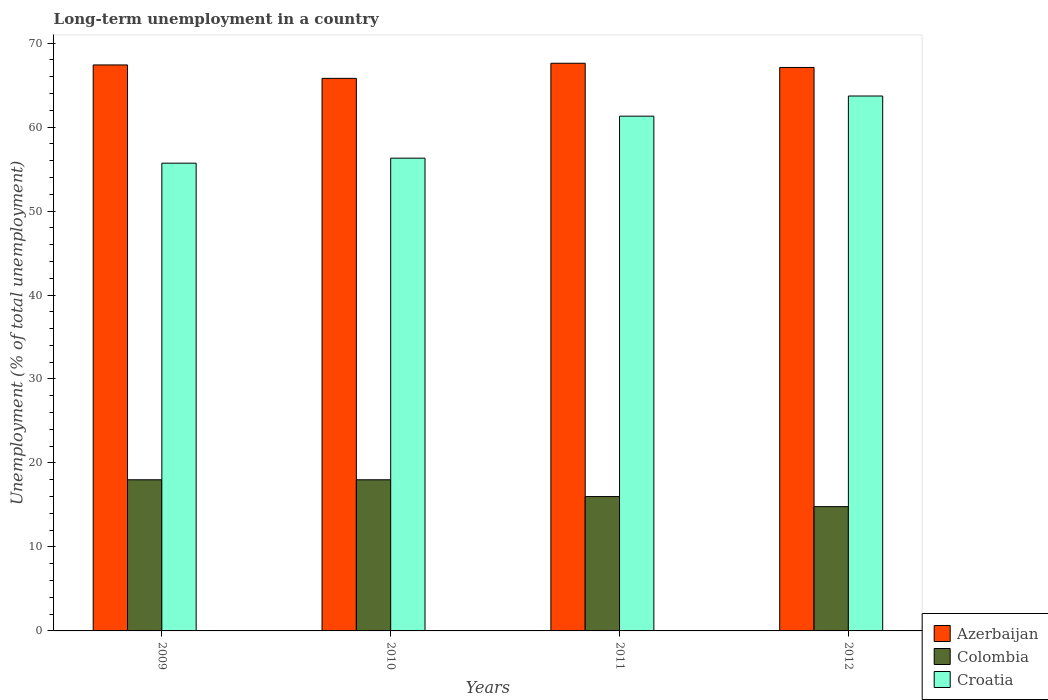Are the number of bars on each tick of the X-axis equal?
Offer a very short reply. Yes. How many bars are there on the 1st tick from the left?
Give a very brief answer. 3. What is the percentage of long-term unemployed population in Azerbaijan in 2009?
Keep it short and to the point. 67.4. Across all years, what is the maximum percentage of long-term unemployed population in Croatia?
Offer a very short reply. 63.7. Across all years, what is the minimum percentage of long-term unemployed population in Croatia?
Offer a very short reply. 55.7. In which year was the percentage of long-term unemployed population in Croatia maximum?
Provide a succinct answer. 2012. In which year was the percentage of long-term unemployed population in Colombia minimum?
Give a very brief answer. 2012. What is the total percentage of long-term unemployed population in Croatia in the graph?
Ensure brevity in your answer.  237. What is the difference between the percentage of long-term unemployed population in Croatia in 2010 and that in 2012?
Make the answer very short. -7.4. What is the difference between the percentage of long-term unemployed population in Colombia in 2010 and the percentage of long-term unemployed population in Azerbaijan in 2009?
Provide a short and direct response. -49.4. What is the average percentage of long-term unemployed population in Azerbaijan per year?
Make the answer very short. 66.98. In the year 2011, what is the difference between the percentage of long-term unemployed population in Colombia and percentage of long-term unemployed population in Azerbaijan?
Provide a succinct answer. -51.6. In how many years, is the percentage of long-term unemployed population in Croatia greater than 68 %?
Ensure brevity in your answer.  0. What is the ratio of the percentage of long-term unemployed population in Colombia in 2010 to that in 2011?
Provide a short and direct response. 1.12. Is the percentage of long-term unemployed population in Azerbaijan in 2010 less than that in 2012?
Offer a very short reply. Yes. What is the difference between the highest and the second highest percentage of long-term unemployed population in Croatia?
Give a very brief answer. 2.4. What is the difference between the highest and the lowest percentage of long-term unemployed population in Colombia?
Provide a short and direct response. 3.2. What does the 3rd bar from the left in 2009 represents?
Ensure brevity in your answer.  Croatia. What does the 2nd bar from the right in 2010 represents?
Your answer should be compact. Colombia. How many years are there in the graph?
Offer a terse response. 4. Does the graph contain any zero values?
Give a very brief answer. No. What is the title of the graph?
Make the answer very short. Long-term unemployment in a country. Does "Namibia" appear as one of the legend labels in the graph?
Provide a succinct answer. No. What is the label or title of the X-axis?
Provide a short and direct response. Years. What is the label or title of the Y-axis?
Offer a very short reply. Unemployment (% of total unemployment). What is the Unemployment (% of total unemployment) in Azerbaijan in 2009?
Offer a very short reply. 67.4. What is the Unemployment (% of total unemployment) of Colombia in 2009?
Keep it short and to the point. 18. What is the Unemployment (% of total unemployment) of Croatia in 2009?
Offer a terse response. 55.7. What is the Unemployment (% of total unemployment) of Azerbaijan in 2010?
Keep it short and to the point. 65.8. What is the Unemployment (% of total unemployment) in Colombia in 2010?
Give a very brief answer. 18. What is the Unemployment (% of total unemployment) in Croatia in 2010?
Give a very brief answer. 56.3. What is the Unemployment (% of total unemployment) in Azerbaijan in 2011?
Ensure brevity in your answer.  67.6. What is the Unemployment (% of total unemployment) in Colombia in 2011?
Your answer should be compact. 16. What is the Unemployment (% of total unemployment) in Croatia in 2011?
Make the answer very short. 61.3. What is the Unemployment (% of total unemployment) of Azerbaijan in 2012?
Your answer should be compact. 67.1. What is the Unemployment (% of total unemployment) of Colombia in 2012?
Give a very brief answer. 14.8. What is the Unemployment (% of total unemployment) of Croatia in 2012?
Your answer should be very brief. 63.7. Across all years, what is the maximum Unemployment (% of total unemployment) of Azerbaijan?
Your response must be concise. 67.6. Across all years, what is the maximum Unemployment (% of total unemployment) in Colombia?
Your answer should be very brief. 18. Across all years, what is the maximum Unemployment (% of total unemployment) in Croatia?
Your response must be concise. 63.7. Across all years, what is the minimum Unemployment (% of total unemployment) of Azerbaijan?
Offer a terse response. 65.8. Across all years, what is the minimum Unemployment (% of total unemployment) in Colombia?
Offer a very short reply. 14.8. Across all years, what is the minimum Unemployment (% of total unemployment) in Croatia?
Provide a short and direct response. 55.7. What is the total Unemployment (% of total unemployment) in Azerbaijan in the graph?
Make the answer very short. 267.9. What is the total Unemployment (% of total unemployment) in Colombia in the graph?
Make the answer very short. 66.8. What is the total Unemployment (% of total unemployment) in Croatia in the graph?
Ensure brevity in your answer.  237. What is the difference between the Unemployment (% of total unemployment) of Croatia in 2009 and that in 2011?
Make the answer very short. -5.6. What is the difference between the Unemployment (% of total unemployment) of Azerbaijan in 2010 and that in 2011?
Offer a very short reply. -1.8. What is the difference between the Unemployment (% of total unemployment) of Colombia in 2010 and that in 2011?
Give a very brief answer. 2. What is the difference between the Unemployment (% of total unemployment) in Azerbaijan in 2010 and that in 2012?
Offer a very short reply. -1.3. What is the difference between the Unemployment (% of total unemployment) in Colombia in 2010 and that in 2012?
Provide a short and direct response. 3.2. What is the difference between the Unemployment (% of total unemployment) of Croatia in 2010 and that in 2012?
Offer a very short reply. -7.4. What is the difference between the Unemployment (% of total unemployment) of Azerbaijan in 2009 and the Unemployment (% of total unemployment) of Colombia in 2010?
Your answer should be compact. 49.4. What is the difference between the Unemployment (% of total unemployment) of Colombia in 2009 and the Unemployment (% of total unemployment) of Croatia in 2010?
Provide a short and direct response. -38.3. What is the difference between the Unemployment (% of total unemployment) of Azerbaijan in 2009 and the Unemployment (% of total unemployment) of Colombia in 2011?
Keep it short and to the point. 51.4. What is the difference between the Unemployment (% of total unemployment) in Azerbaijan in 2009 and the Unemployment (% of total unemployment) in Croatia in 2011?
Give a very brief answer. 6.1. What is the difference between the Unemployment (% of total unemployment) in Colombia in 2009 and the Unemployment (% of total unemployment) in Croatia in 2011?
Provide a succinct answer. -43.3. What is the difference between the Unemployment (% of total unemployment) of Azerbaijan in 2009 and the Unemployment (% of total unemployment) of Colombia in 2012?
Your answer should be compact. 52.6. What is the difference between the Unemployment (% of total unemployment) in Azerbaijan in 2009 and the Unemployment (% of total unemployment) in Croatia in 2012?
Offer a very short reply. 3.7. What is the difference between the Unemployment (% of total unemployment) in Colombia in 2009 and the Unemployment (% of total unemployment) in Croatia in 2012?
Keep it short and to the point. -45.7. What is the difference between the Unemployment (% of total unemployment) of Azerbaijan in 2010 and the Unemployment (% of total unemployment) of Colombia in 2011?
Ensure brevity in your answer.  49.8. What is the difference between the Unemployment (% of total unemployment) in Azerbaijan in 2010 and the Unemployment (% of total unemployment) in Croatia in 2011?
Make the answer very short. 4.5. What is the difference between the Unemployment (% of total unemployment) of Colombia in 2010 and the Unemployment (% of total unemployment) of Croatia in 2011?
Your answer should be very brief. -43.3. What is the difference between the Unemployment (% of total unemployment) in Azerbaijan in 2010 and the Unemployment (% of total unemployment) in Colombia in 2012?
Give a very brief answer. 51. What is the difference between the Unemployment (% of total unemployment) of Azerbaijan in 2010 and the Unemployment (% of total unemployment) of Croatia in 2012?
Your answer should be compact. 2.1. What is the difference between the Unemployment (% of total unemployment) in Colombia in 2010 and the Unemployment (% of total unemployment) in Croatia in 2012?
Provide a succinct answer. -45.7. What is the difference between the Unemployment (% of total unemployment) in Azerbaijan in 2011 and the Unemployment (% of total unemployment) in Colombia in 2012?
Your answer should be very brief. 52.8. What is the difference between the Unemployment (% of total unemployment) of Azerbaijan in 2011 and the Unemployment (% of total unemployment) of Croatia in 2012?
Your answer should be very brief. 3.9. What is the difference between the Unemployment (% of total unemployment) in Colombia in 2011 and the Unemployment (% of total unemployment) in Croatia in 2012?
Your answer should be very brief. -47.7. What is the average Unemployment (% of total unemployment) in Azerbaijan per year?
Make the answer very short. 66.97. What is the average Unemployment (% of total unemployment) in Croatia per year?
Provide a succinct answer. 59.25. In the year 2009, what is the difference between the Unemployment (% of total unemployment) in Azerbaijan and Unemployment (% of total unemployment) in Colombia?
Give a very brief answer. 49.4. In the year 2009, what is the difference between the Unemployment (% of total unemployment) of Colombia and Unemployment (% of total unemployment) of Croatia?
Your answer should be very brief. -37.7. In the year 2010, what is the difference between the Unemployment (% of total unemployment) in Azerbaijan and Unemployment (% of total unemployment) in Colombia?
Make the answer very short. 47.8. In the year 2010, what is the difference between the Unemployment (% of total unemployment) of Colombia and Unemployment (% of total unemployment) of Croatia?
Give a very brief answer. -38.3. In the year 2011, what is the difference between the Unemployment (% of total unemployment) of Azerbaijan and Unemployment (% of total unemployment) of Colombia?
Ensure brevity in your answer.  51.6. In the year 2011, what is the difference between the Unemployment (% of total unemployment) of Colombia and Unemployment (% of total unemployment) of Croatia?
Ensure brevity in your answer.  -45.3. In the year 2012, what is the difference between the Unemployment (% of total unemployment) of Azerbaijan and Unemployment (% of total unemployment) of Colombia?
Provide a succinct answer. 52.3. In the year 2012, what is the difference between the Unemployment (% of total unemployment) of Azerbaijan and Unemployment (% of total unemployment) of Croatia?
Keep it short and to the point. 3.4. In the year 2012, what is the difference between the Unemployment (% of total unemployment) in Colombia and Unemployment (% of total unemployment) in Croatia?
Provide a succinct answer. -48.9. What is the ratio of the Unemployment (% of total unemployment) of Azerbaijan in 2009 to that in 2010?
Make the answer very short. 1.02. What is the ratio of the Unemployment (% of total unemployment) of Croatia in 2009 to that in 2010?
Your response must be concise. 0.99. What is the ratio of the Unemployment (% of total unemployment) in Azerbaijan in 2009 to that in 2011?
Make the answer very short. 1. What is the ratio of the Unemployment (% of total unemployment) of Colombia in 2009 to that in 2011?
Offer a very short reply. 1.12. What is the ratio of the Unemployment (% of total unemployment) in Croatia in 2009 to that in 2011?
Provide a short and direct response. 0.91. What is the ratio of the Unemployment (% of total unemployment) of Colombia in 2009 to that in 2012?
Keep it short and to the point. 1.22. What is the ratio of the Unemployment (% of total unemployment) of Croatia in 2009 to that in 2012?
Provide a succinct answer. 0.87. What is the ratio of the Unemployment (% of total unemployment) in Azerbaijan in 2010 to that in 2011?
Your answer should be very brief. 0.97. What is the ratio of the Unemployment (% of total unemployment) in Colombia in 2010 to that in 2011?
Provide a short and direct response. 1.12. What is the ratio of the Unemployment (% of total unemployment) of Croatia in 2010 to that in 2011?
Your answer should be very brief. 0.92. What is the ratio of the Unemployment (% of total unemployment) in Azerbaijan in 2010 to that in 2012?
Your answer should be compact. 0.98. What is the ratio of the Unemployment (% of total unemployment) of Colombia in 2010 to that in 2012?
Your response must be concise. 1.22. What is the ratio of the Unemployment (% of total unemployment) in Croatia in 2010 to that in 2012?
Provide a succinct answer. 0.88. What is the ratio of the Unemployment (% of total unemployment) of Azerbaijan in 2011 to that in 2012?
Offer a very short reply. 1.01. What is the ratio of the Unemployment (% of total unemployment) of Colombia in 2011 to that in 2012?
Offer a very short reply. 1.08. What is the ratio of the Unemployment (% of total unemployment) in Croatia in 2011 to that in 2012?
Give a very brief answer. 0.96. What is the difference between the highest and the second highest Unemployment (% of total unemployment) of Azerbaijan?
Ensure brevity in your answer.  0.2. What is the difference between the highest and the lowest Unemployment (% of total unemployment) of Azerbaijan?
Provide a succinct answer. 1.8. 